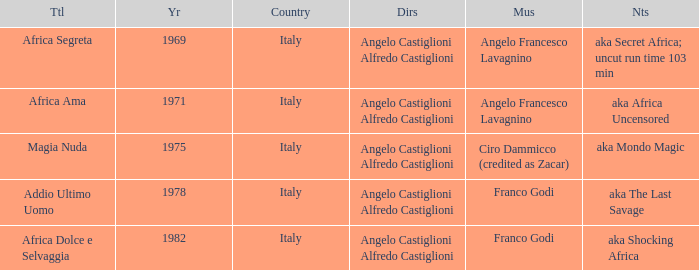Which music has the notes of AKA Africa Uncensored? Angelo Francesco Lavagnino. 